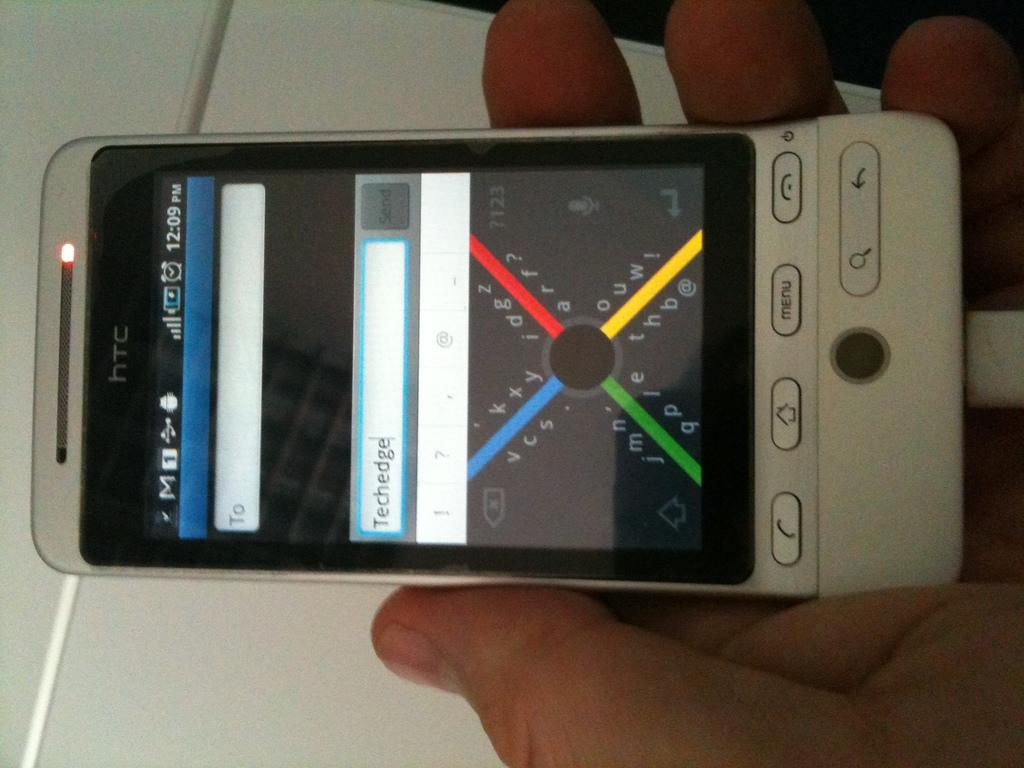<image>
Describe the image concisely. An HTC phone shows the time as 12:09PM while somebody plays a game 